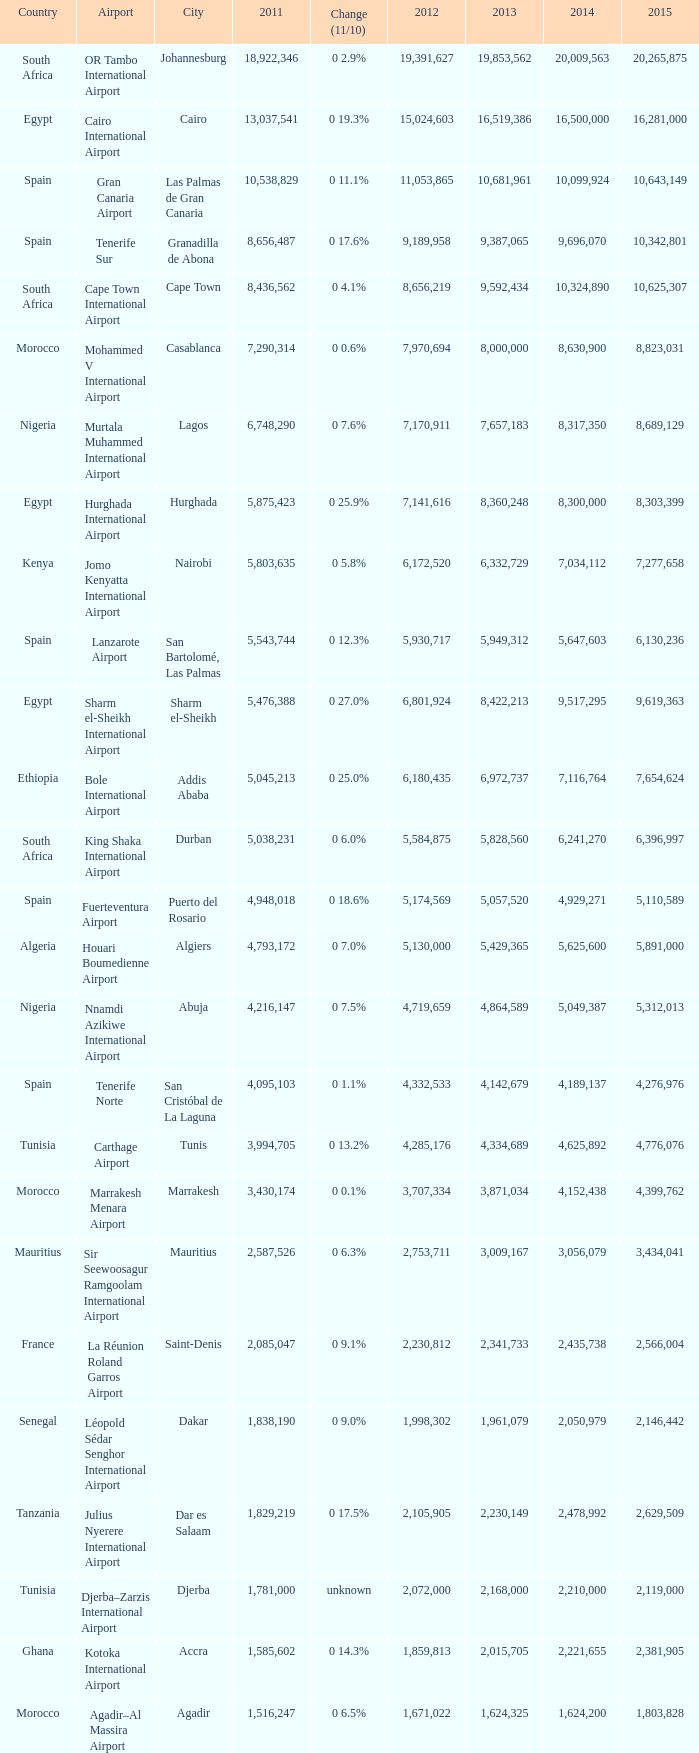Which 2011 has an Airport of bole international airport? 5045213.0. 